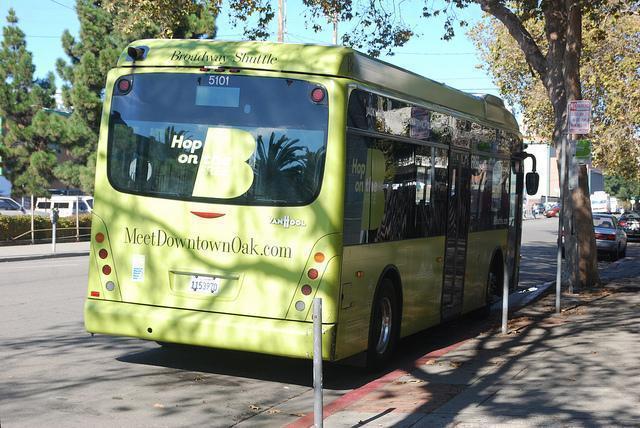What city is this?
Pick the correct solution from the four options below to address the question.
Options: Chicago, fremont, oakland, broadway. Oakland. 